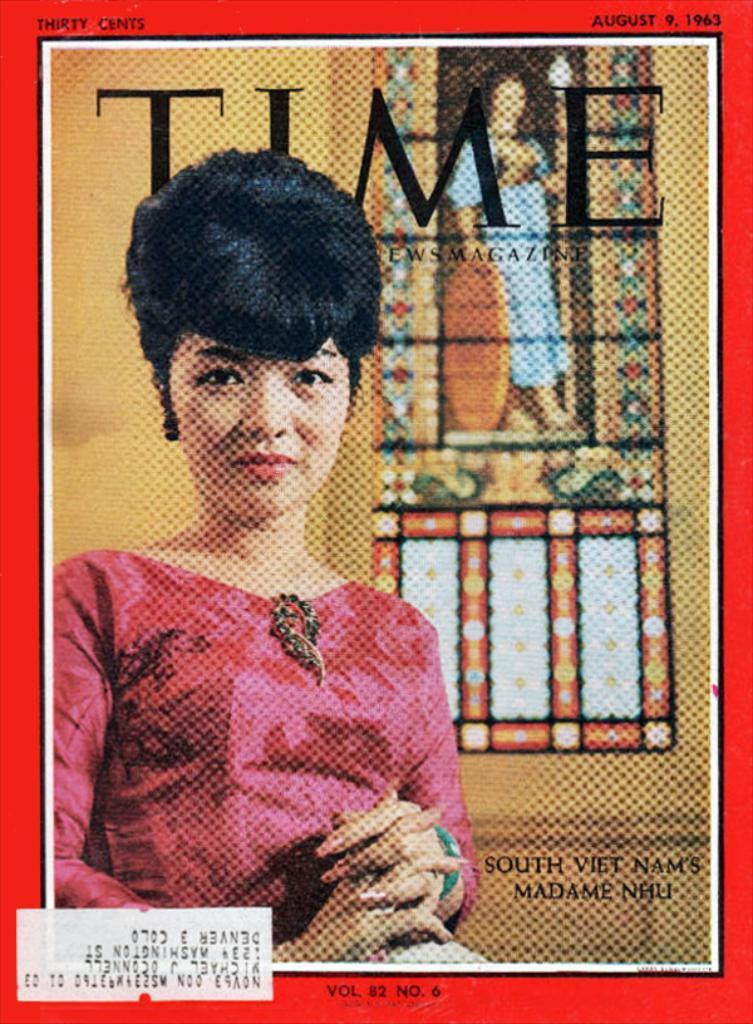Could you give a brief overview of what you see in this image? In this picture we can see a poster, on this poster we can see people and some text on it. 